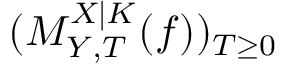<formula> <loc_0><loc_0><loc_500><loc_500>( M _ { Y , T } ^ { X | K } ( f ) ) _ { T \geq 0 }</formula> 